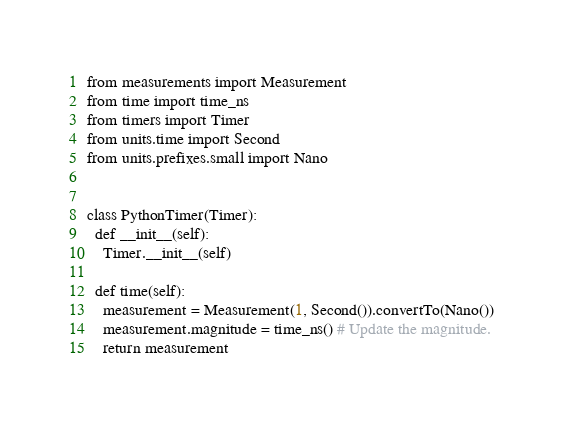Convert code to text. <code><loc_0><loc_0><loc_500><loc_500><_Python_>

from measurements import Measurement
from time import time_ns
from timers import Timer
from units.time import Second
from units.prefixes.small import Nano


class PythonTimer(Timer):
  def __init__(self):
    Timer.__init__(self)

  def time(self):
    measurement = Measurement(1, Second()).convertTo(Nano())
    measurement.magnitude = time_ns() # Update the magnitude.
    return measurement

</code> 